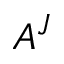Convert formula to latex. <formula><loc_0><loc_0><loc_500><loc_500>A ^ { J }</formula> 